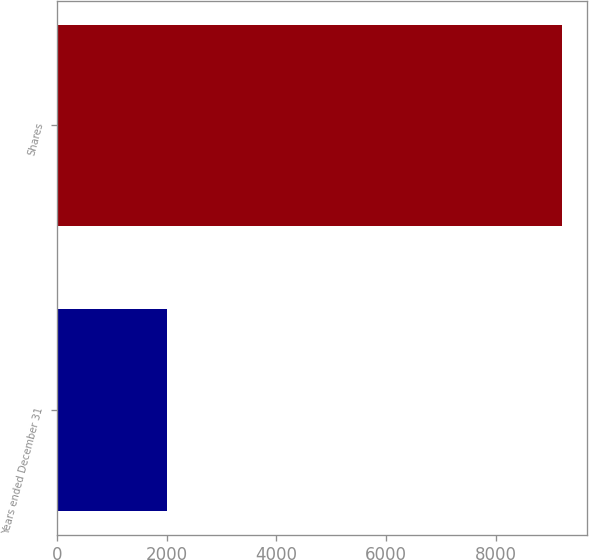Convert chart to OTSL. <chart><loc_0><loc_0><loc_500><loc_500><bar_chart><fcel>Years ended December 31<fcel>Shares<nl><fcel>2016<fcel>9211<nl></chart> 